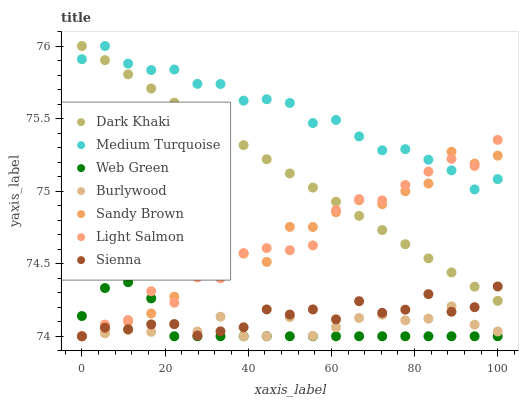Does Web Green have the minimum area under the curve?
Answer yes or no. Yes. Does Medium Turquoise have the maximum area under the curve?
Answer yes or no. Yes. Does Light Salmon have the minimum area under the curve?
Answer yes or no. No. Does Light Salmon have the maximum area under the curve?
Answer yes or no. No. Is Dark Khaki the smoothest?
Answer yes or no. Yes. Is Light Salmon the roughest?
Answer yes or no. Yes. Is Burlywood the smoothest?
Answer yes or no. No. Is Burlywood the roughest?
Answer yes or no. No. Does Sienna have the lowest value?
Answer yes or no. Yes. Does Dark Khaki have the lowest value?
Answer yes or no. No. Does Medium Turquoise have the highest value?
Answer yes or no. Yes. Does Light Salmon have the highest value?
Answer yes or no. No. Is Burlywood less than Dark Khaki?
Answer yes or no. Yes. Is Medium Turquoise greater than Burlywood?
Answer yes or no. Yes. Does Light Salmon intersect Burlywood?
Answer yes or no. Yes. Is Light Salmon less than Burlywood?
Answer yes or no. No. Is Light Salmon greater than Burlywood?
Answer yes or no. No. Does Burlywood intersect Dark Khaki?
Answer yes or no. No. 